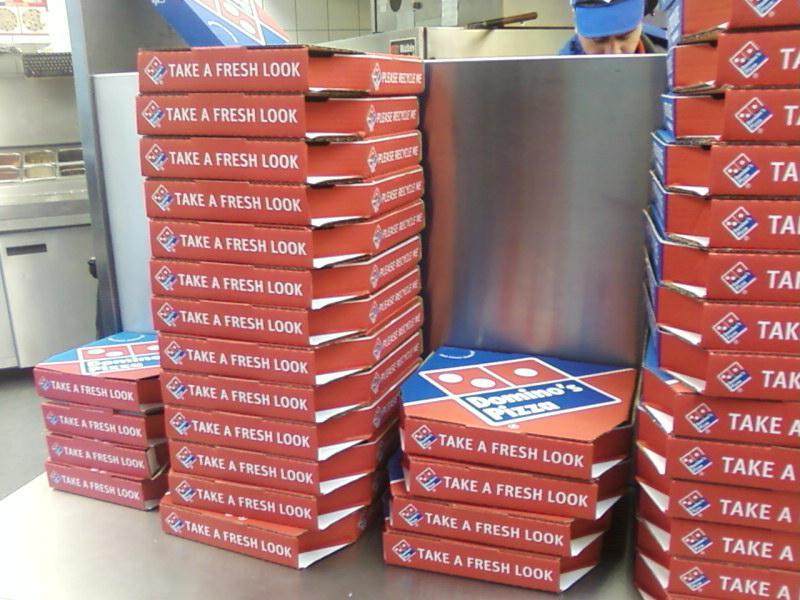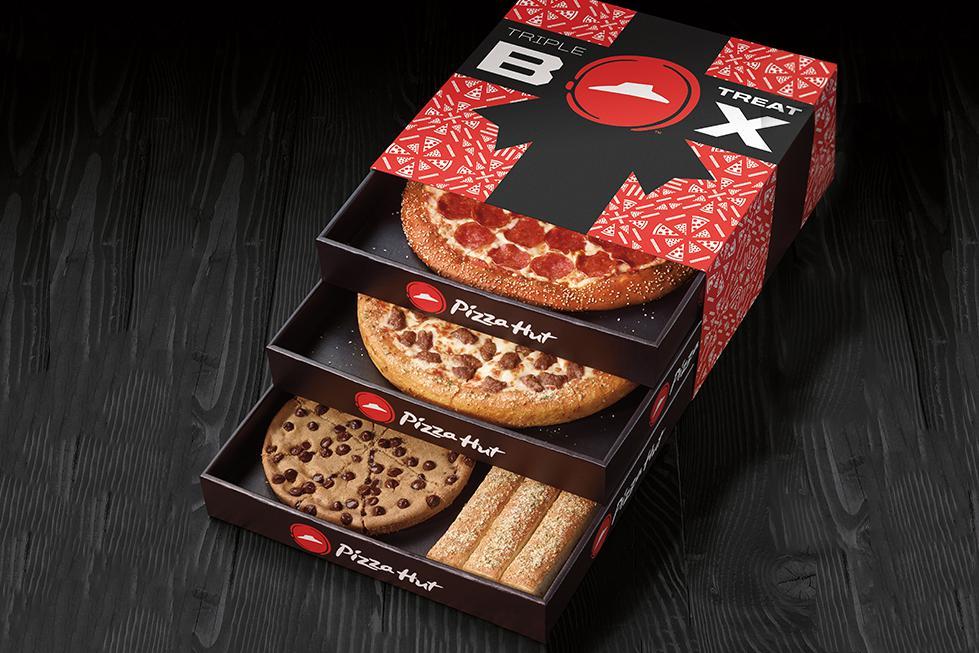The first image is the image on the left, the second image is the image on the right. Examine the images to the left and right. Is the description "Both images contain pizza boxes." accurate? Answer yes or no. Yes. The first image is the image on the left, the second image is the image on the right. Given the left and right images, does the statement "There are at least five towers of pizza boxes." hold true? Answer yes or no. No. 